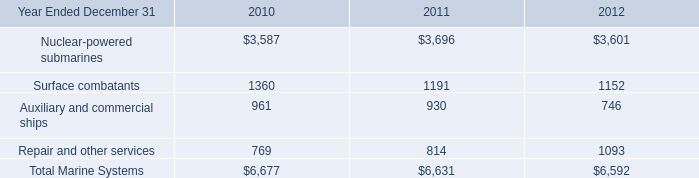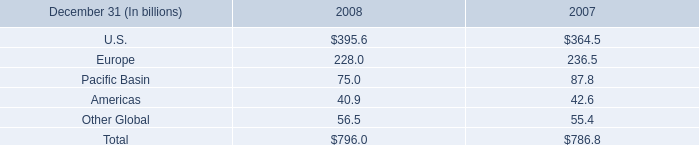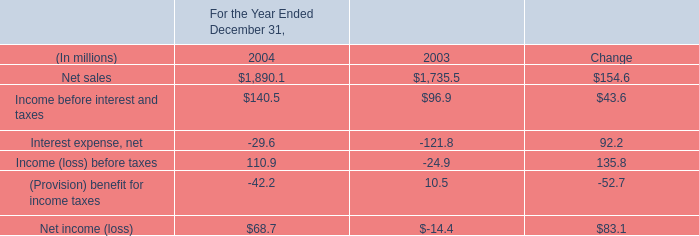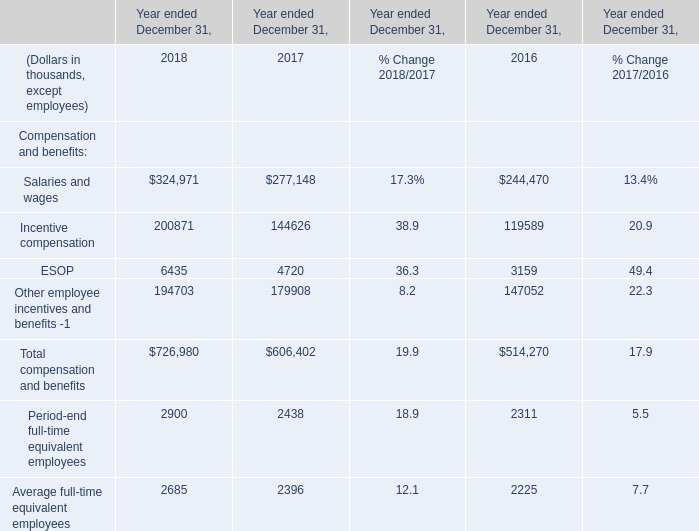What is the value of the Total compensation and benefits in 2017 ended December 31? (in thousand) 
Answer: 606402. 